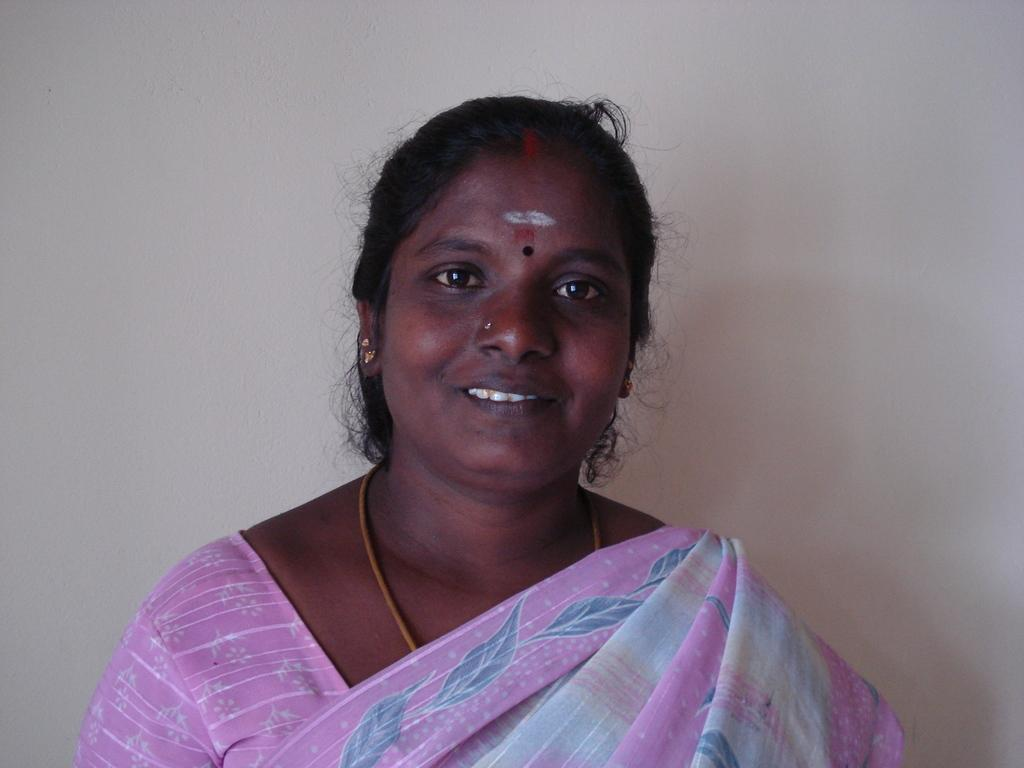Who is the main subject in the image? There is a lady in the center of the image. What is the lady doing in the image? The lady is standing and smiling. What is the lady wearing in the image? The lady is wearing a pink color saree. What can be seen in the background of the image? There is a wall in the background of the image. What news is the lady sharing with the man in the image? There is no man present in the image, and the lady is not sharing any news. 